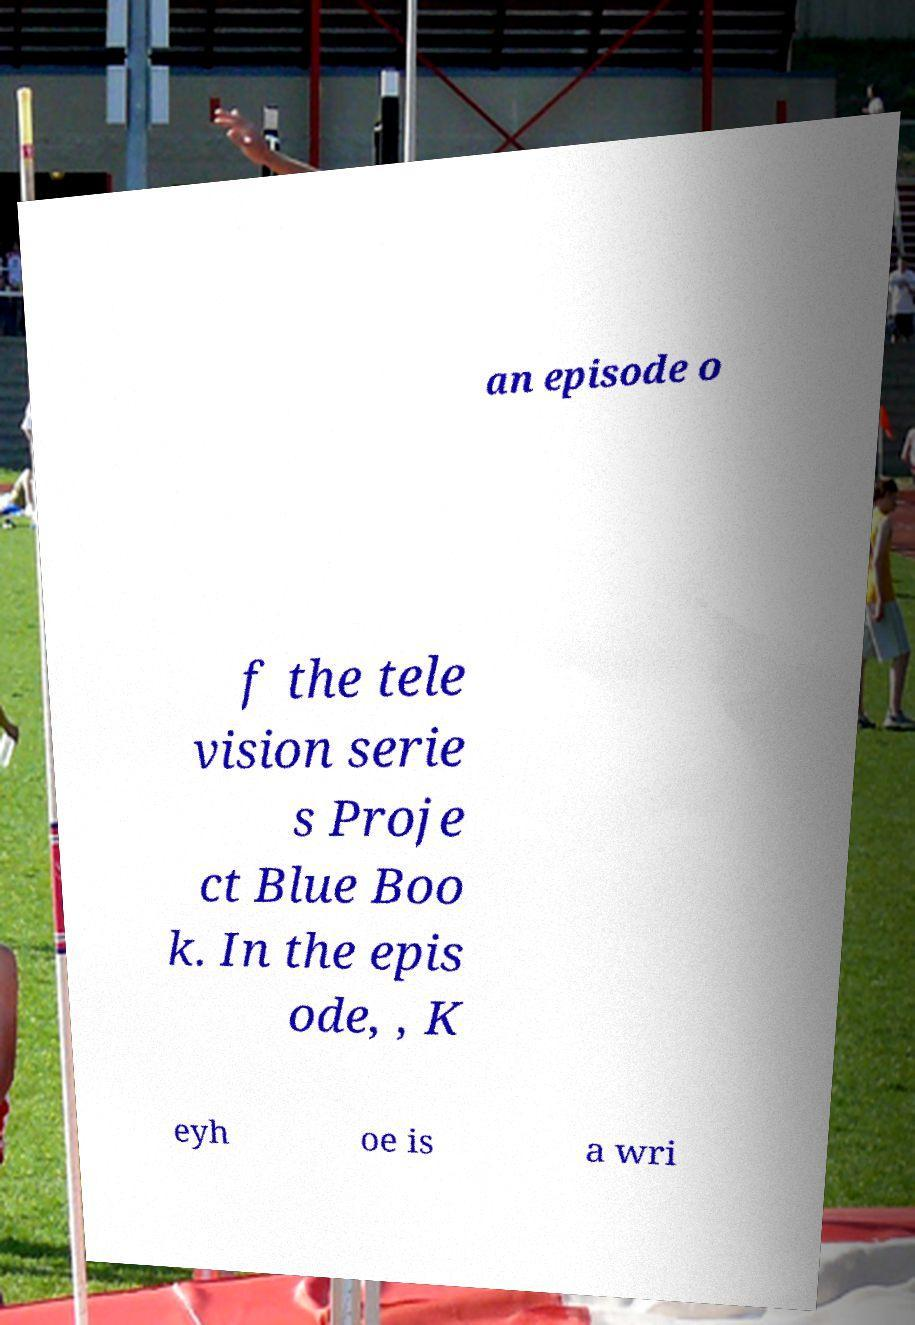Can you accurately transcribe the text from the provided image for me? an episode o f the tele vision serie s Proje ct Blue Boo k. In the epis ode, , K eyh oe is a wri 